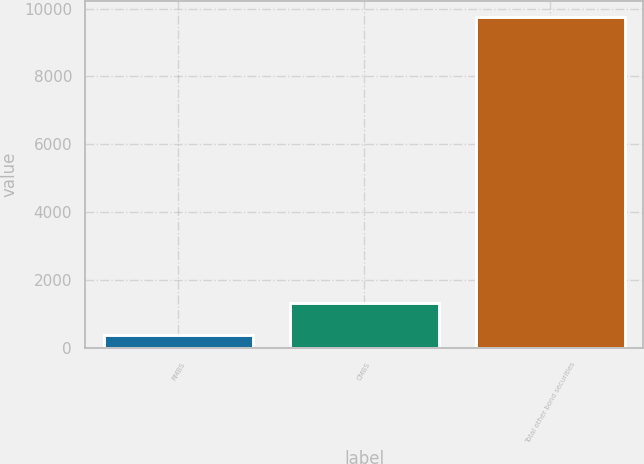Convert chart. <chart><loc_0><loc_0><loc_500><loc_500><bar_chart><fcel>RMBS<fcel>CMBS<fcel>Total other bond securities<nl><fcel>396<fcel>1330.8<fcel>9744<nl></chart> 